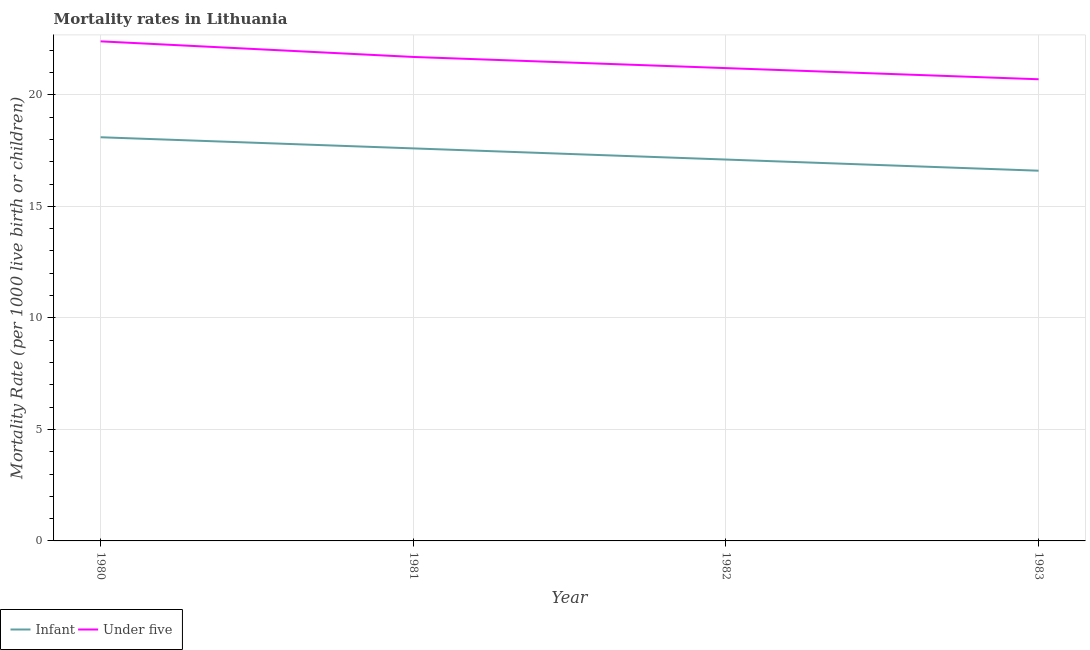Is the number of lines equal to the number of legend labels?
Provide a short and direct response. Yes. Across all years, what is the maximum under-5 mortality rate?
Provide a succinct answer. 22.4. Across all years, what is the minimum under-5 mortality rate?
Your answer should be very brief. 20.7. In which year was the infant mortality rate minimum?
Provide a short and direct response. 1983. What is the total under-5 mortality rate in the graph?
Ensure brevity in your answer.  86. What is the difference between the under-5 mortality rate in 1982 and that in 1983?
Offer a terse response. 0.5. What is the difference between the infant mortality rate in 1980 and the under-5 mortality rate in 1982?
Offer a very short reply. -3.1. What is the average infant mortality rate per year?
Offer a very short reply. 17.35. In the year 1983, what is the difference between the infant mortality rate and under-5 mortality rate?
Offer a terse response. -4.1. In how many years, is the under-5 mortality rate greater than 16?
Give a very brief answer. 4. What is the ratio of the under-5 mortality rate in 1980 to that in 1982?
Offer a very short reply. 1.06. Is the under-5 mortality rate in 1981 less than that in 1982?
Give a very brief answer. No. What is the difference between the highest and the second highest under-5 mortality rate?
Give a very brief answer. 0.7. What is the difference between the highest and the lowest under-5 mortality rate?
Your response must be concise. 1.7. Does the infant mortality rate monotonically increase over the years?
Your answer should be very brief. No. Is the infant mortality rate strictly greater than the under-5 mortality rate over the years?
Keep it short and to the point. No. What is the difference between two consecutive major ticks on the Y-axis?
Ensure brevity in your answer.  5. Are the values on the major ticks of Y-axis written in scientific E-notation?
Your answer should be very brief. No. Does the graph contain any zero values?
Keep it short and to the point. No. How many legend labels are there?
Ensure brevity in your answer.  2. How are the legend labels stacked?
Ensure brevity in your answer.  Horizontal. What is the title of the graph?
Your answer should be compact. Mortality rates in Lithuania. What is the label or title of the Y-axis?
Your answer should be compact. Mortality Rate (per 1000 live birth or children). What is the Mortality Rate (per 1000 live birth or children) in Infant in 1980?
Ensure brevity in your answer.  18.1. What is the Mortality Rate (per 1000 live birth or children) in Under five in 1980?
Provide a succinct answer. 22.4. What is the Mortality Rate (per 1000 live birth or children) of Under five in 1981?
Ensure brevity in your answer.  21.7. What is the Mortality Rate (per 1000 live birth or children) in Infant in 1982?
Ensure brevity in your answer.  17.1. What is the Mortality Rate (per 1000 live birth or children) of Under five in 1982?
Your response must be concise. 21.2. What is the Mortality Rate (per 1000 live birth or children) in Under five in 1983?
Give a very brief answer. 20.7. Across all years, what is the maximum Mortality Rate (per 1000 live birth or children) of Infant?
Provide a short and direct response. 18.1. Across all years, what is the maximum Mortality Rate (per 1000 live birth or children) of Under five?
Provide a short and direct response. 22.4. Across all years, what is the minimum Mortality Rate (per 1000 live birth or children) of Infant?
Give a very brief answer. 16.6. Across all years, what is the minimum Mortality Rate (per 1000 live birth or children) in Under five?
Your answer should be very brief. 20.7. What is the total Mortality Rate (per 1000 live birth or children) in Infant in the graph?
Offer a terse response. 69.4. What is the difference between the Mortality Rate (per 1000 live birth or children) of Under five in 1980 and that in 1981?
Keep it short and to the point. 0.7. What is the difference between the Mortality Rate (per 1000 live birth or children) in Infant in 1980 and that in 1983?
Your answer should be compact. 1.5. What is the difference between the Mortality Rate (per 1000 live birth or children) in Infant in 1981 and that in 1982?
Make the answer very short. 0.5. What is the difference between the Mortality Rate (per 1000 live birth or children) of Under five in 1981 and that in 1982?
Offer a terse response. 0.5. What is the difference between the Mortality Rate (per 1000 live birth or children) of Infant in 1981 and that in 1983?
Your response must be concise. 1. What is the difference between the Mortality Rate (per 1000 live birth or children) in Infant in 1982 and that in 1983?
Make the answer very short. 0.5. What is the difference between the Mortality Rate (per 1000 live birth or children) in Under five in 1982 and that in 1983?
Give a very brief answer. 0.5. What is the difference between the Mortality Rate (per 1000 live birth or children) in Infant in 1980 and the Mortality Rate (per 1000 live birth or children) in Under five in 1981?
Give a very brief answer. -3.6. What is the difference between the Mortality Rate (per 1000 live birth or children) of Infant in 1981 and the Mortality Rate (per 1000 live birth or children) of Under five in 1983?
Your answer should be very brief. -3.1. What is the difference between the Mortality Rate (per 1000 live birth or children) in Infant in 1982 and the Mortality Rate (per 1000 live birth or children) in Under five in 1983?
Your answer should be very brief. -3.6. What is the average Mortality Rate (per 1000 live birth or children) in Infant per year?
Give a very brief answer. 17.35. In the year 1980, what is the difference between the Mortality Rate (per 1000 live birth or children) of Infant and Mortality Rate (per 1000 live birth or children) of Under five?
Keep it short and to the point. -4.3. In the year 1981, what is the difference between the Mortality Rate (per 1000 live birth or children) in Infant and Mortality Rate (per 1000 live birth or children) in Under five?
Give a very brief answer. -4.1. In the year 1982, what is the difference between the Mortality Rate (per 1000 live birth or children) in Infant and Mortality Rate (per 1000 live birth or children) in Under five?
Provide a succinct answer. -4.1. What is the ratio of the Mortality Rate (per 1000 live birth or children) in Infant in 1980 to that in 1981?
Provide a short and direct response. 1.03. What is the ratio of the Mortality Rate (per 1000 live birth or children) in Under five in 1980 to that in 1981?
Keep it short and to the point. 1.03. What is the ratio of the Mortality Rate (per 1000 live birth or children) of Infant in 1980 to that in 1982?
Your response must be concise. 1.06. What is the ratio of the Mortality Rate (per 1000 live birth or children) of Under five in 1980 to that in 1982?
Keep it short and to the point. 1.06. What is the ratio of the Mortality Rate (per 1000 live birth or children) of Infant in 1980 to that in 1983?
Provide a succinct answer. 1.09. What is the ratio of the Mortality Rate (per 1000 live birth or children) of Under five in 1980 to that in 1983?
Make the answer very short. 1.08. What is the ratio of the Mortality Rate (per 1000 live birth or children) in Infant in 1981 to that in 1982?
Offer a terse response. 1.03. What is the ratio of the Mortality Rate (per 1000 live birth or children) of Under five in 1981 to that in 1982?
Give a very brief answer. 1.02. What is the ratio of the Mortality Rate (per 1000 live birth or children) of Infant in 1981 to that in 1983?
Your answer should be compact. 1.06. What is the ratio of the Mortality Rate (per 1000 live birth or children) of Under five in 1981 to that in 1983?
Provide a short and direct response. 1.05. What is the ratio of the Mortality Rate (per 1000 live birth or children) in Infant in 1982 to that in 1983?
Make the answer very short. 1.03. What is the ratio of the Mortality Rate (per 1000 live birth or children) in Under five in 1982 to that in 1983?
Your answer should be very brief. 1.02. What is the difference between the highest and the second highest Mortality Rate (per 1000 live birth or children) of Under five?
Offer a terse response. 0.7. 